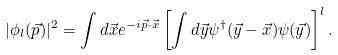Convert formula to latex. <formula><loc_0><loc_0><loc_500><loc_500>| \phi _ { l } ( \vec { p } ) | ^ { 2 } = \int d \vec { x } e ^ { - i \vec { p } \cdot \vec { x } } \left [ \int d \vec { y } \psi ^ { \dagger } ( \vec { y } - \vec { x } ) \psi ( \vec { y } ) \right ] ^ { l } .</formula> 